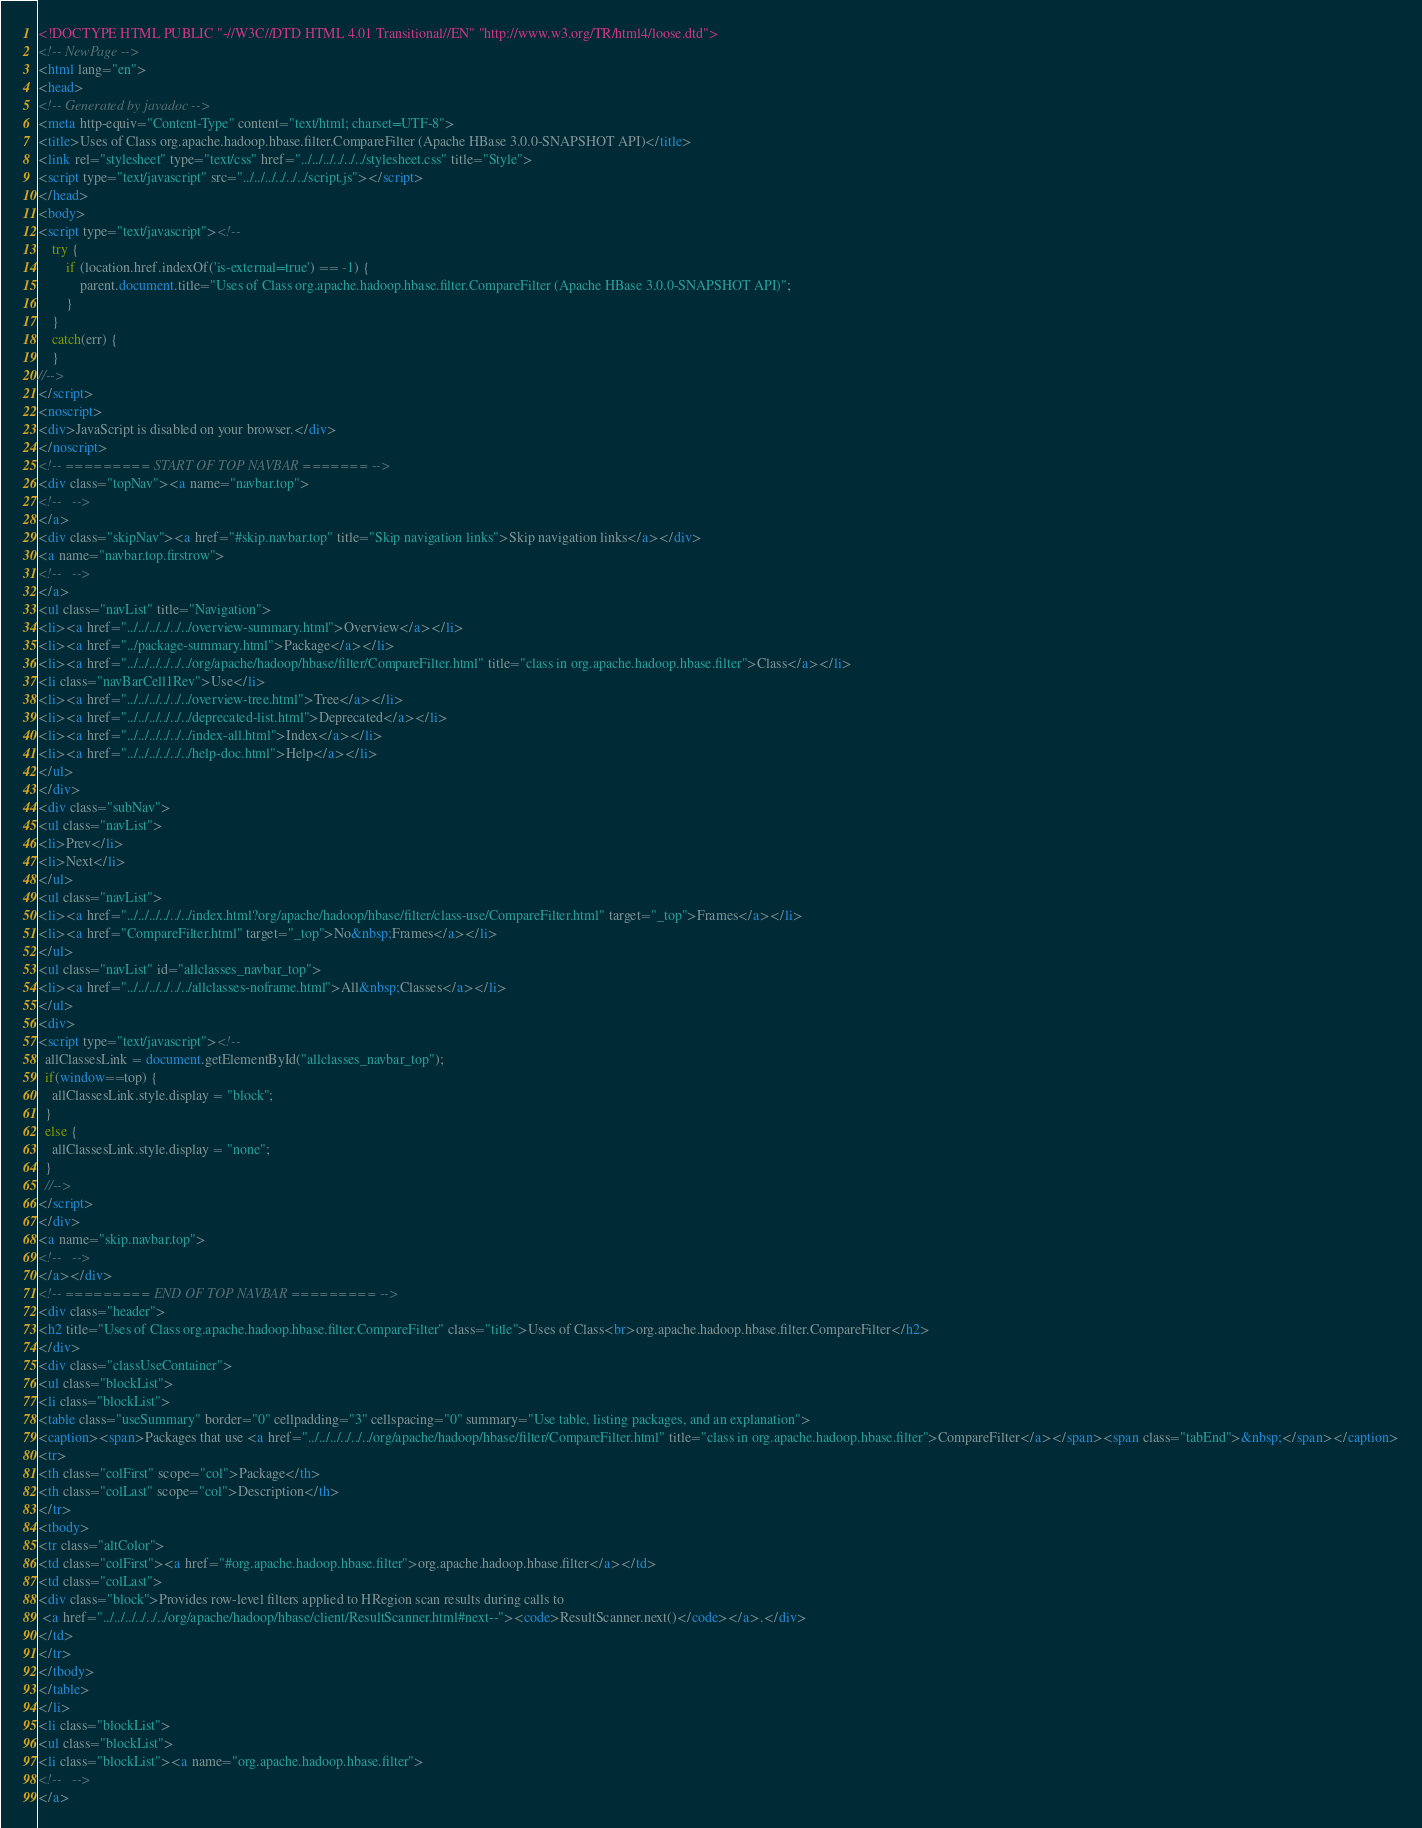<code> <loc_0><loc_0><loc_500><loc_500><_HTML_><!DOCTYPE HTML PUBLIC "-//W3C//DTD HTML 4.01 Transitional//EN" "http://www.w3.org/TR/html4/loose.dtd">
<!-- NewPage -->
<html lang="en">
<head>
<!-- Generated by javadoc -->
<meta http-equiv="Content-Type" content="text/html; charset=UTF-8">
<title>Uses of Class org.apache.hadoop.hbase.filter.CompareFilter (Apache HBase 3.0.0-SNAPSHOT API)</title>
<link rel="stylesheet" type="text/css" href="../../../../../../stylesheet.css" title="Style">
<script type="text/javascript" src="../../../../../../script.js"></script>
</head>
<body>
<script type="text/javascript"><!--
    try {
        if (location.href.indexOf('is-external=true') == -1) {
            parent.document.title="Uses of Class org.apache.hadoop.hbase.filter.CompareFilter (Apache HBase 3.0.0-SNAPSHOT API)";
        }
    }
    catch(err) {
    }
//-->
</script>
<noscript>
<div>JavaScript is disabled on your browser.</div>
</noscript>
<!-- ========= START OF TOP NAVBAR ======= -->
<div class="topNav"><a name="navbar.top">
<!--   -->
</a>
<div class="skipNav"><a href="#skip.navbar.top" title="Skip navigation links">Skip navigation links</a></div>
<a name="navbar.top.firstrow">
<!--   -->
</a>
<ul class="navList" title="Navigation">
<li><a href="../../../../../../overview-summary.html">Overview</a></li>
<li><a href="../package-summary.html">Package</a></li>
<li><a href="../../../../../../org/apache/hadoop/hbase/filter/CompareFilter.html" title="class in org.apache.hadoop.hbase.filter">Class</a></li>
<li class="navBarCell1Rev">Use</li>
<li><a href="../../../../../../overview-tree.html">Tree</a></li>
<li><a href="../../../../../../deprecated-list.html">Deprecated</a></li>
<li><a href="../../../../../../index-all.html">Index</a></li>
<li><a href="../../../../../../help-doc.html">Help</a></li>
</ul>
</div>
<div class="subNav">
<ul class="navList">
<li>Prev</li>
<li>Next</li>
</ul>
<ul class="navList">
<li><a href="../../../../../../index.html?org/apache/hadoop/hbase/filter/class-use/CompareFilter.html" target="_top">Frames</a></li>
<li><a href="CompareFilter.html" target="_top">No&nbsp;Frames</a></li>
</ul>
<ul class="navList" id="allclasses_navbar_top">
<li><a href="../../../../../../allclasses-noframe.html">All&nbsp;Classes</a></li>
</ul>
<div>
<script type="text/javascript"><!--
  allClassesLink = document.getElementById("allclasses_navbar_top");
  if(window==top) {
    allClassesLink.style.display = "block";
  }
  else {
    allClassesLink.style.display = "none";
  }
  //-->
</script>
</div>
<a name="skip.navbar.top">
<!--   -->
</a></div>
<!-- ========= END OF TOP NAVBAR ========= -->
<div class="header">
<h2 title="Uses of Class org.apache.hadoop.hbase.filter.CompareFilter" class="title">Uses of Class<br>org.apache.hadoop.hbase.filter.CompareFilter</h2>
</div>
<div class="classUseContainer">
<ul class="blockList">
<li class="blockList">
<table class="useSummary" border="0" cellpadding="3" cellspacing="0" summary="Use table, listing packages, and an explanation">
<caption><span>Packages that use <a href="../../../../../../org/apache/hadoop/hbase/filter/CompareFilter.html" title="class in org.apache.hadoop.hbase.filter">CompareFilter</a></span><span class="tabEnd">&nbsp;</span></caption>
<tr>
<th class="colFirst" scope="col">Package</th>
<th class="colLast" scope="col">Description</th>
</tr>
<tbody>
<tr class="altColor">
<td class="colFirst"><a href="#org.apache.hadoop.hbase.filter">org.apache.hadoop.hbase.filter</a></td>
<td class="colLast">
<div class="block">Provides row-level filters applied to HRegion scan results during calls to
 <a href="../../../../../../org/apache/hadoop/hbase/client/ResultScanner.html#next--"><code>ResultScanner.next()</code></a>.</div>
</td>
</tr>
</tbody>
</table>
</li>
<li class="blockList">
<ul class="blockList">
<li class="blockList"><a name="org.apache.hadoop.hbase.filter">
<!--   -->
</a></code> 